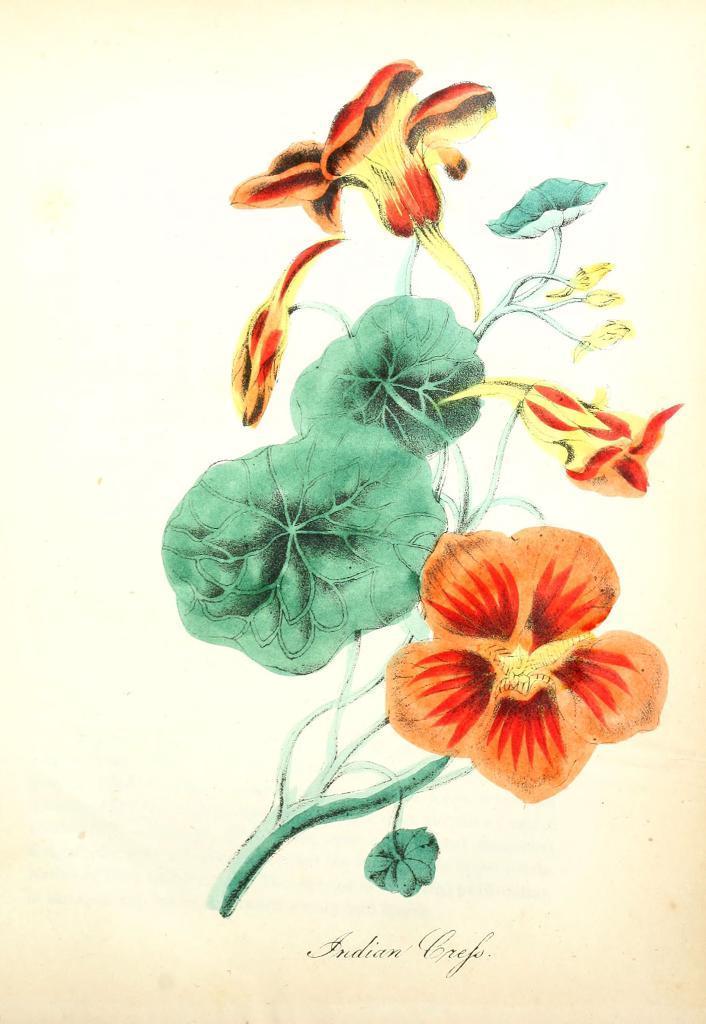Could you give a brief overview of what you see in this image? In this image I can see the painting of few flowers which are orange and yellow in color to a plant which is green in color on the cream colored background. 